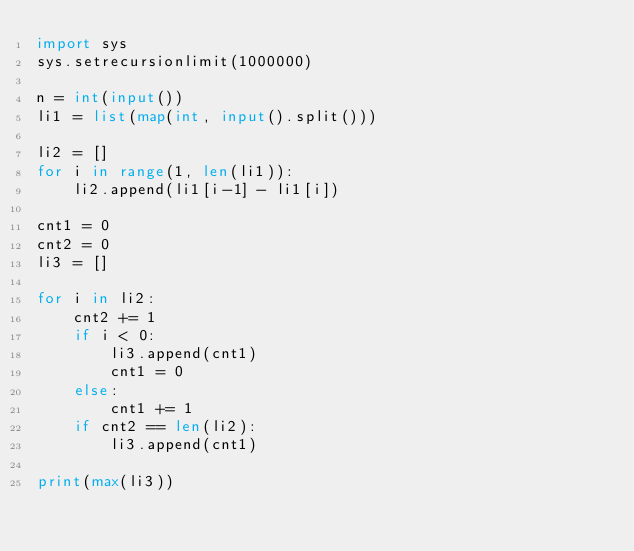Convert code to text. <code><loc_0><loc_0><loc_500><loc_500><_Python_>import sys
sys.setrecursionlimit(1000000)

n = int(input())
li1 = list(map(int, input().split()))

li2 = []
for i in range(1, len(li1)):
    li2.append(li1[i-1] - li1[i])
    
cnt1 = 0
cnt2 = 0
li3 = []

for i in li2:
    cnt2 += 1
    if i < 0:
        li3.append(cnt1)
        cnt1 = 0
    else:
        cnt1 += 1
    if cnt2 == len(li2):
        li3.append(cnt1)

print(max(li3))</code> 